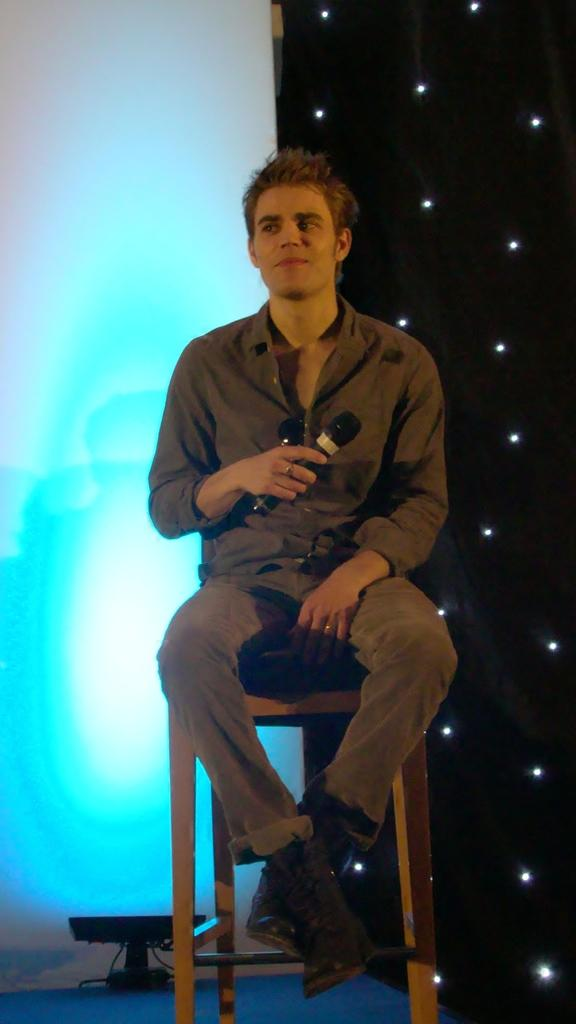Who is present in the image? There is a man in the image. What is the man doing in the image? The man is sitting on a seating stool and holding a mic in his hands. What can be seen in the background of the image? There are decor lights in the background of the image. What type of rod is the man using to hold the substance in the image? There is no rod or substance present in the image. The man is holding a mic, not a rod or substance. 